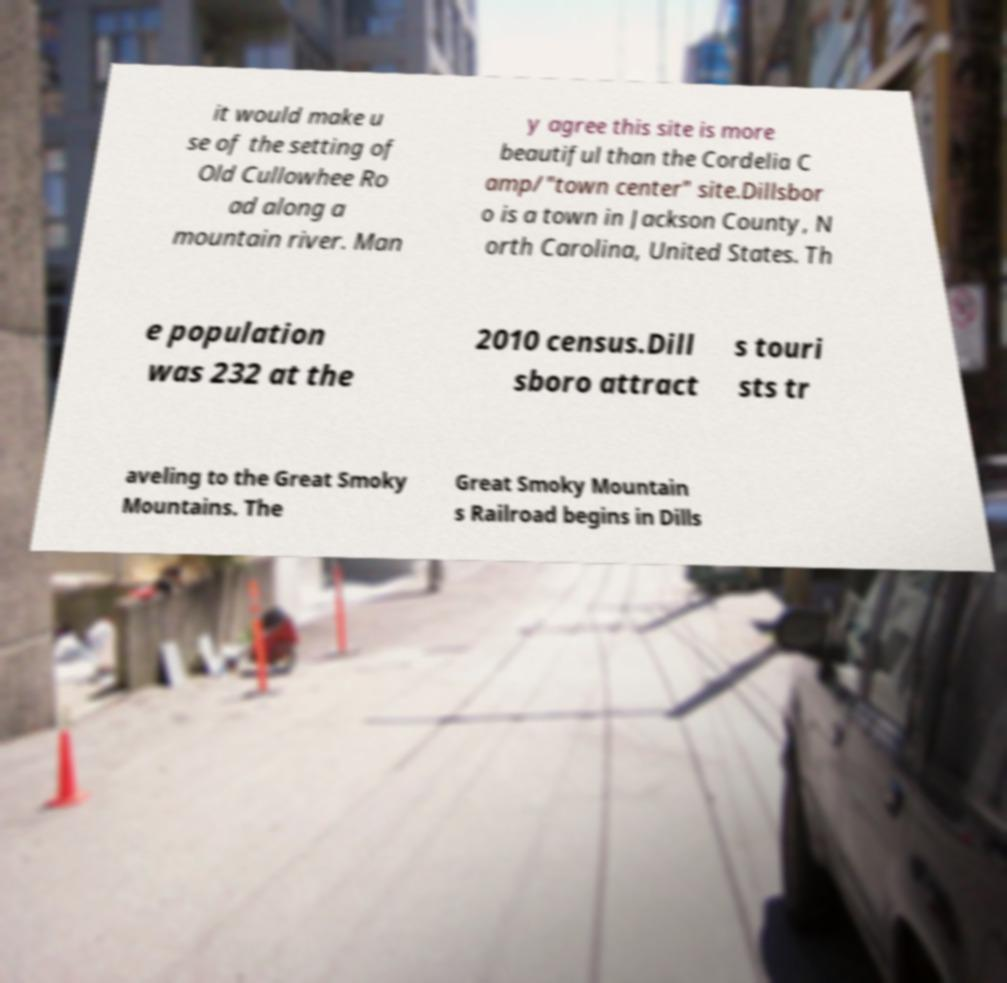Can you accurately transcribe the text from the provided image for me? it would make u se of the setting of Old Cullowhee Ro ad along a mountain river. Man y agree this site is more beautiful than the Cordelia C amp/"town center" site.Dillsbor o is a town in Jackson County, N orth Carolina, United States. Th e population was 232 at the 2010 census.Dill sboro attract s touri sts tr aveling to the Great Smoky Mountains. The Great Smoky Mountain s Railroad begins in Dills 